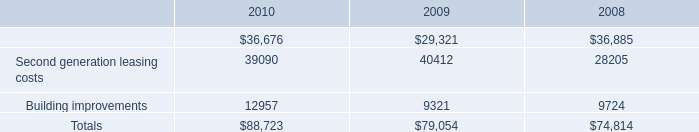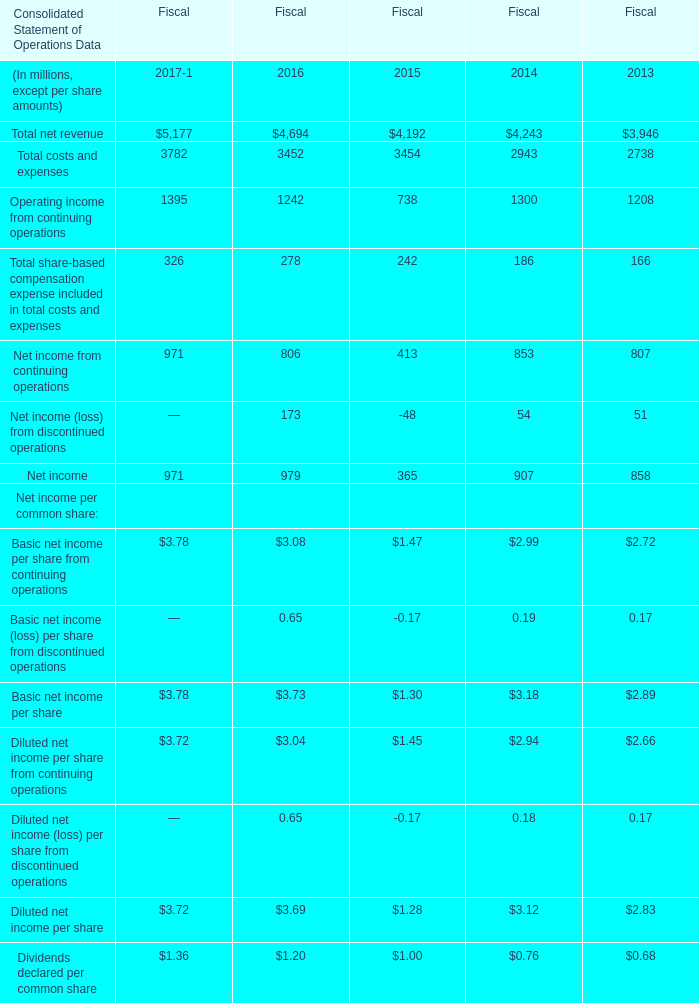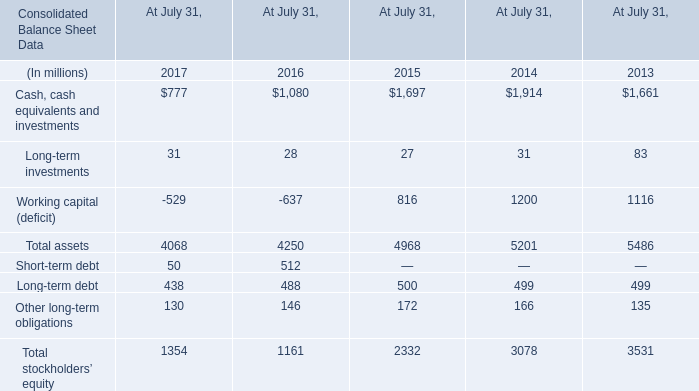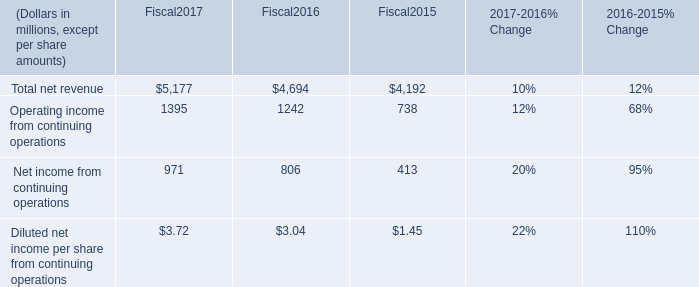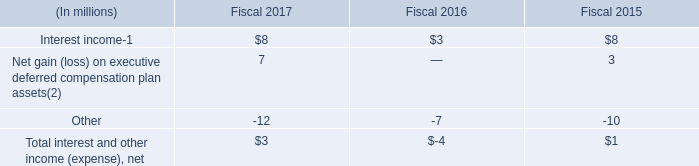Does the value of Total net revenue in 2016 greater than that in2017?) 
Answer: no. 